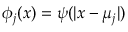<formula> <loc_0><loc_0><loc_500><loc_500>\phi _ { j } ( x ) = \psi ( | x - \mu _ { j } | )</formula> 